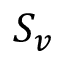Convert formula to latex. <formula><loc_0><loc_0><loc_500><loc_500>S _ { v }</formula> 